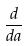<formula> <loc_0><loc_0><loc_500><loc_500>\frac { d } { d a }</formula> 